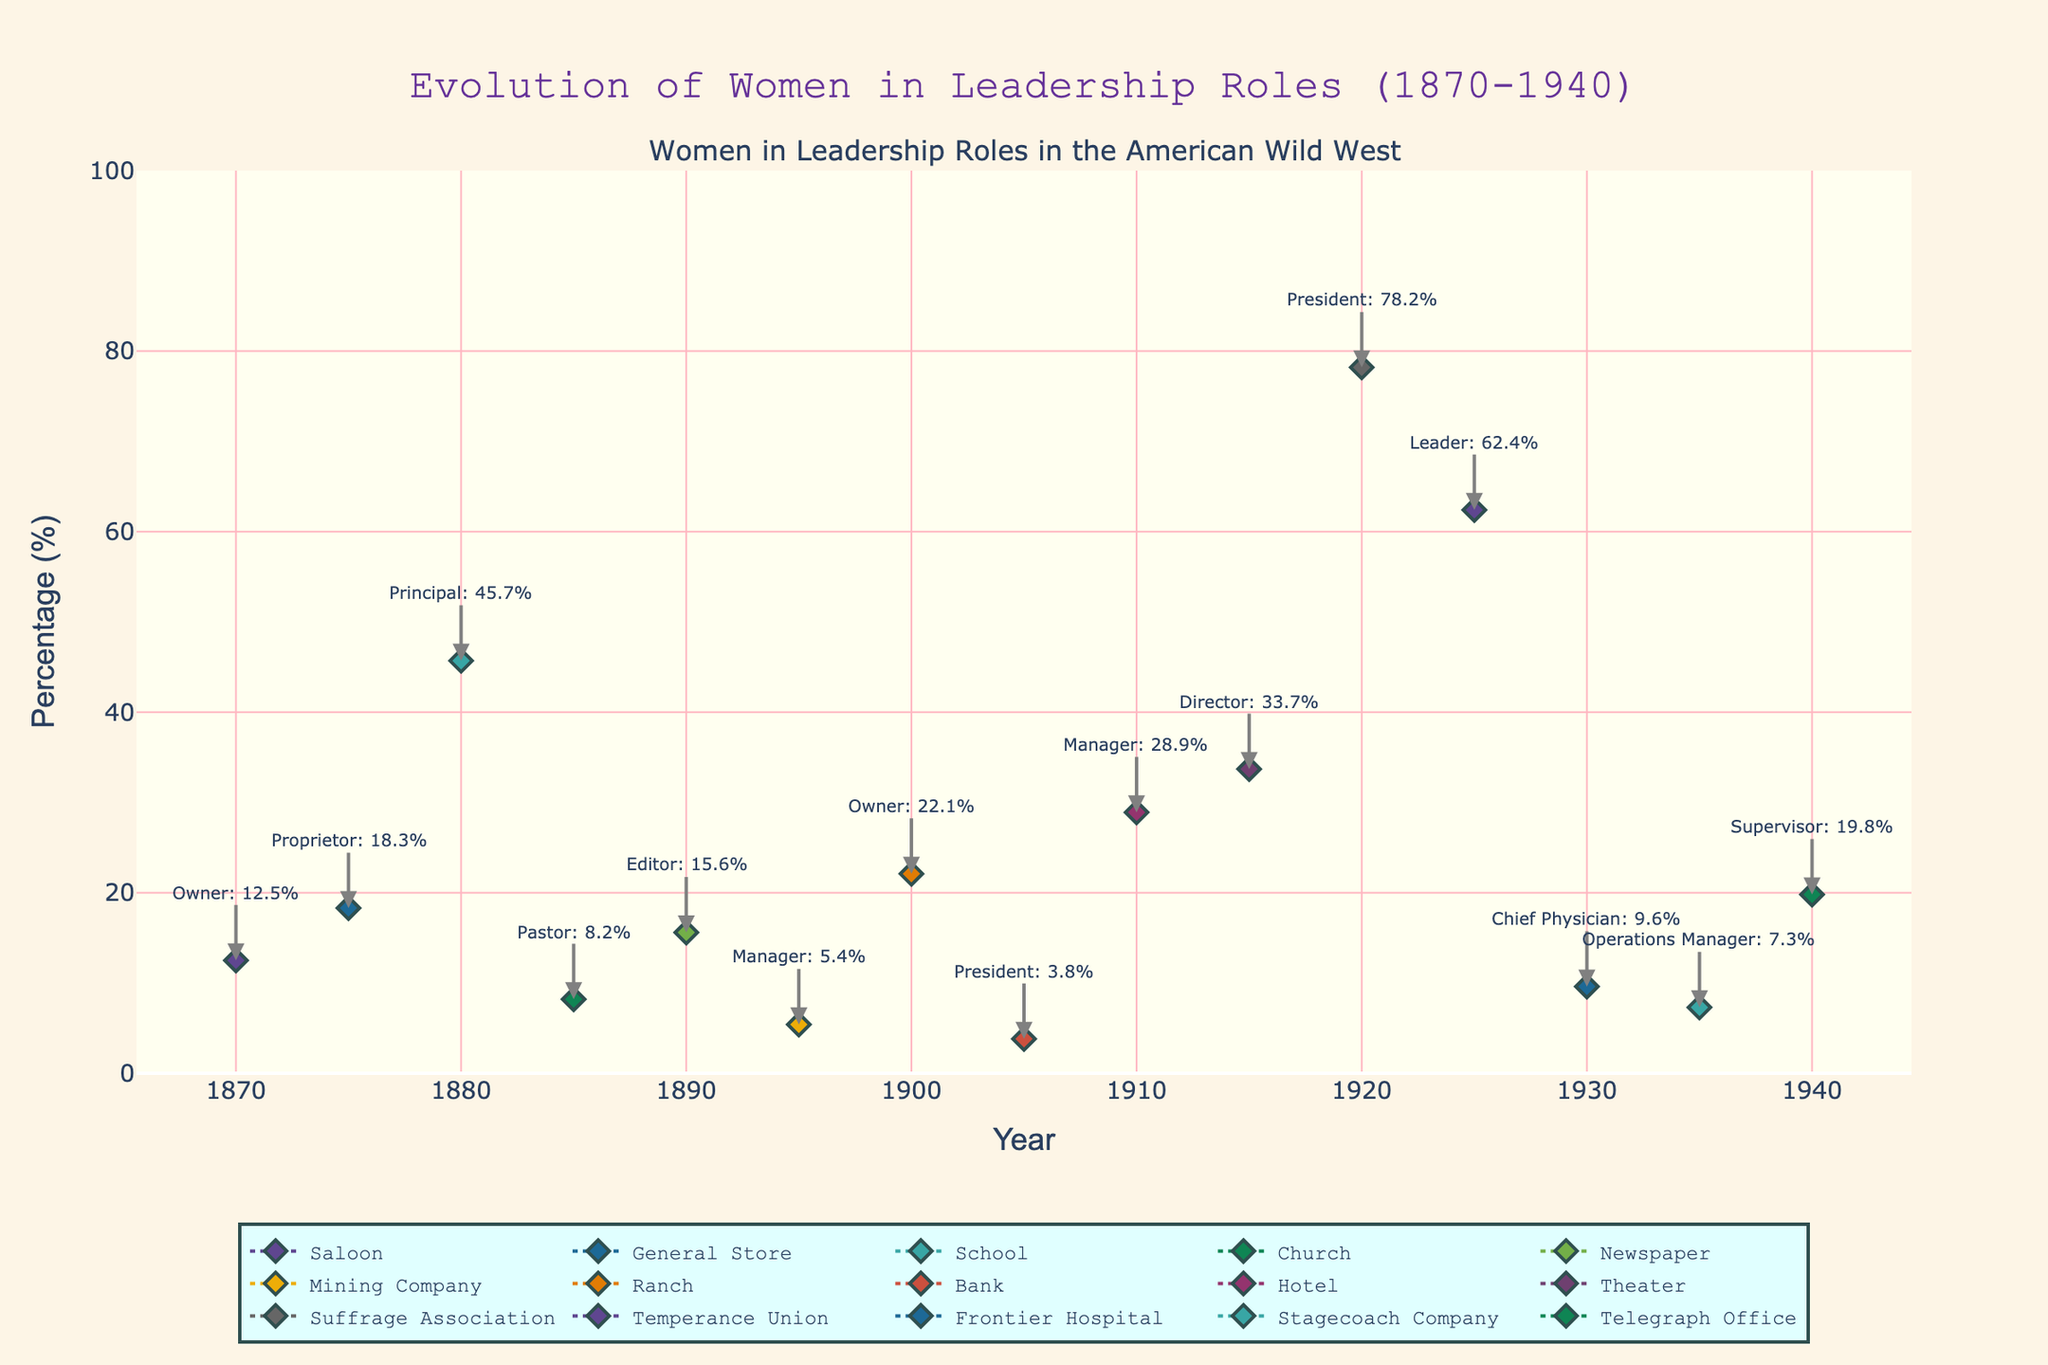what is the title of the plot? The title appears at the top of the figure, typically in larger text and possibly in a different color for emphasis.
Answer: Evolution of Women in Leadership Roles (1870-1940) In which year does the percentage of women leaders in the Suffrage Association peak? Look for the year next to the highest point on the line representing the Suffrage Association.
Answer: 1920 Which occupation had the lowest representation of women in leadership roles, and what was the percentage? Identify the smallest value on the y-axis and find the corresponding occupation on the plot.
Answer: Bank, 3.8% What is the average percentage of women in leadership roles in the 1920s and 1930s? Locate the points for 1920 and 1925 for the 1920s, and 1930 and 1935 for the 1930s, add their percentages and divide by the number of points.
Answer: (78.2 + 62.4 + 9.6 + 7.3) / 4 = 39.375% Which occupation shows the most substantial increase in female representation between their first and last data points? Calculate the difference for each occupation by subtracting the first percentage from the last percentage for that occupation, then find the maximum increase.
Answer: Suffrage Association, 78.2% How does the percentage of women leaders in General Stores in 1875 compare to that in Hotels in 1910? Find the percentage of women leaders in General Stores in 1875 and compare it to that in Hotels in 1910.
Answer: General Store (18.3%), Hotel (28.9%) What is the trend for women leaders in School positions over time? Look for the line representing the School occupation and observe the pattern of data points over time.
Answer: The percentage increases over time What was the percentage of women leaders in frontier hospitals in 1930? Find the point on the plot corresponding to Frontier Hospital in 1930.
Answer: 9.6% Which occupation had women as leaders first, and what percentage was it? Look for the earliest year on the x-axis and identify the occupation associated with the point, noting the percentage.
Answer: Saloon, 12.5% Which occupation had the highest representation of women in leadership roles overall? Identify the highest percentage point on the y-axis and find the associated occupation.
Answer: Suffrage Association, 78.2% 